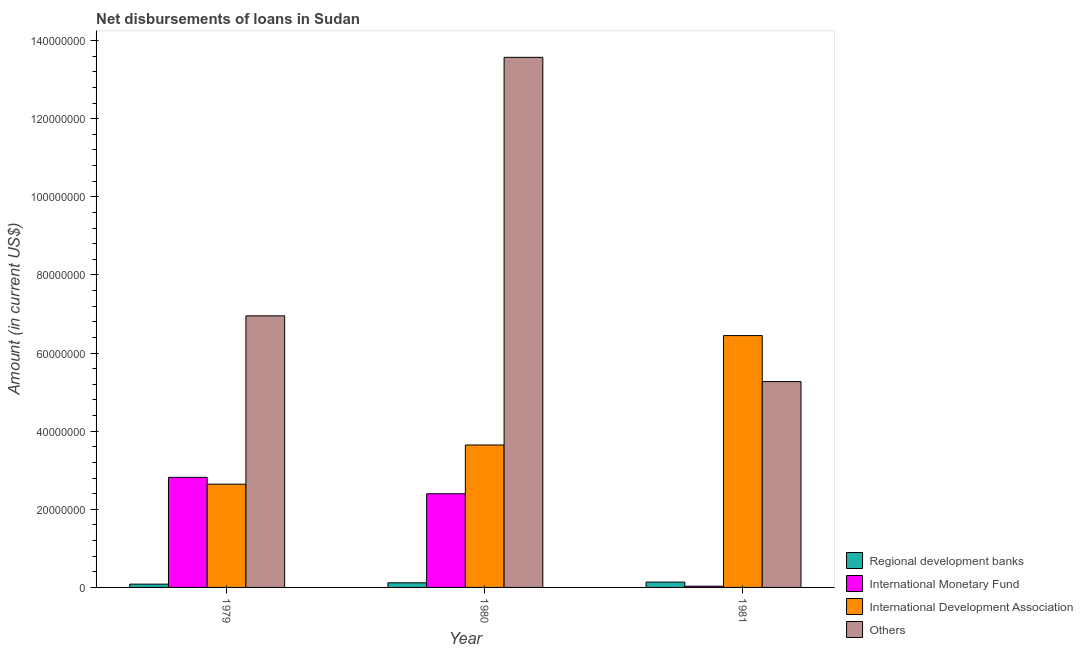Are the number of bars on each tick of the X-axis equal?
Ensure brevity in your answer.  Yes. What is the label of the 1st group of bars from the left?
Provide a succinct answer. 1979. What is the amount of loan disimbursed by international monetary fund in 1979?
Your answer should be very brief. 2.82e+07. Across all years, what is the maximum amount of loan disimbursed by other organisations?
Your answer should be compact. 1.36e+08. Across all years, what is the minimum amount of loan disimbursed by international monetary fund?
Your answer should be compact. 3.20e+05. In which year was the amount of loan disimbursed by international monetary fund maximum?
Your answer should be very brief. 1979. What is the total amount of loan disimbursed by international monetary fund in the graph?
Offer a terse response. 5.25e+07. What is the difference between the amount of loan disimbursed by international development association in 1980 and that in 1981?
Provide a short and direct response. -2.80e+07. What is the difference between the amount of loan disimbursed by other organisations in 1981 and the amount of loan disimbursed by international development association in 1980?
Offer a very short reply. -8.30e+07. What is the average amount of loan disimbursed by international monetary fund per year?
Offer a very short reply. 1.75e+07. In the year 1981, what is the difference between the amount of loan disimbursed by regional development banks and amount of loan disimbursed by international monetary fund?
Your answer should be very brief. 0. What is the ratio of the amount of loan disimbursed by international development association in 1979 to that in 1981?
Offer a terse response. 0.41. Is the amount of loan disimbursed by international development association in 1979 less than that in 1981?
Provide a short and direct response. Yes. Is the difference between the amount of loan disimbursed by international development association in 1979 and 1980 greater than the difference between the amount of loan disimbursed by international monetary fund in 1979 and 1980?
Provide a short and direct response. No. What is the difference between the highest and the second highest amount of loan disimbursed by other organisations?
Offer a very short reply. 6.62e+07. What is the difference between the highest and the lowest amount of loan disimbursed by international development association?
Your answer should be very brief. 3.80e+07. Is the sum of the amount of loan disimbursed by international development association in 1979 and 1981 greater than the maximum amount of loan disimbursed by international monetary fund across all years?
Your response must be concise. Yes. Is it the case that in every year, the sum of the amount of loan disimbursed by international monetary fund and amount of loan disimbursed by international development association is greater than the sum of amount of loan disimbursed by regional development banks and amount of loan disimbursed by other organisations?
Give a very brief answer. No. What does the 2nd bar from the left in 1980 represents?
Offer a very short reply. International Monetary Fund. What does the 2nd bar from the right in 1979 represents?
Make the answer very short. International Development Association. Is it the case that in every year, the sum of the amount of loan disimbursed by regional development banks and amount of loan disimbursed by international monetary fund is greater than the amount of loan disimbursed by international development association?
Your answer should be very brief. No. How many bars are there?
Offer a very short reply. 12. Are all the bars in the graph horizontal?
Your response must be concise. No. How many years are there in the graph?
Your answer should be very brief. 3. Does the graph contain grids?
Your answer should be compact. No. Where does the legend appear in the graph?
Your answer should be compact. Bottom right. How are the legend labels stacked?
Offer a terse response. Vertical. What is the title of the graph?
Your answer should be very brief. Net disbursements of loans in Sudan. What is the label or title of the Y-axis?
Give a very brief answer. Amount (in current US$). What is the Amount (in current US$) of Regional development banks in 1979?
Offer a very short reply. 8.43e+05. What is the Amount (in current US$) in International Monetary Fund in 1979?
Provide a succinct answer. 2.82e+07. What is the Amount (in current US$) of International Development Association in 1979?
Provide a short and direct response. 2.64e+07. What is the Amount (in current US$) of Others in 1979?
Your answer should be compact. 6.95e+07. What is the Amount (in current US$) in Regional development banks in 1980?
Provide a short and direct response. 1.19e+06. What is the Amount (in current US$) of International Monetary Fund in 1980?
Your answer should be very brief. 2.40e+07. What is the Amount (in current US$) of International Development Association in 1980?
Your answer should be very brief. 3.65e+07. What is the Amount (in current US$) in Others in 1980?
Your answer should be very brief. 1.36e+08. What is the Amount (in current US$) of Regional development banks in 1981?
Your answer should be very brief. 1.37e+06. What is the Amount (in current US$) of International Development Association in 1981?
Make the answer very short. 6.45e+07. What is the Amount (in current US$) of Others in 1981?
Your answer should be compact. 5.27e+07. Across all years, what is the maximum Amount (in current US$) in Regional development banks?
Offer a very short reply. 1.37e+06. Across all years, what is the maximum Amount (in current US$) in International Monetary Fund?
Your answer should be very brief. 2.82e+07. Across all years, what is the maximum Amount (in current US$) in International Development Association?
Offer a very short reply. 6.45e+07. Across all years, what is the maximum Amount (in current US$) of Others?
Ensure brevity in your answer.  1.36e+08. Across all years, what is the minimum Amount (in current US$) in Regional development banks?
Make the answer very short. 8.43e+05. Across all years, what is the minimum Amount (in current US$) of International Monetary Fund?
Offer a terse response. 3.20e+05. Across all years, what is the minimum Amount (in current US$) of International Development Association?
Make the answer very short. 2.64e+07. Across all years, what is the minimum Amount (in current US$) of Others?
Give a very brief answer. 5.27e+07. What is the total Amount (in current US$) in Regional development banks in the graph?
Provide a short and direct response. 3.40e+06. What is the total Amount (in current US$) of International Monetary Fund in the graph?
Make the answer very short. 5.25e+07. What is the total Amount (in current US$) of International Development Association in the graph?
Make the answer very short. 1.27e+08. What is the total Amount (in current US$) in Others in the graph?
Your answer should be very brief. 2.58e+08. What is the difference between the Amount (in current US$) of Regional development banks in 1979 and that in 1980?
Provide a short and direct response. -3.46e+05. What is the difference between the Amount (in current US$) in International Monetary Fund in 1979 and that in 1980?
Your answer should be compact. 4.20e+06. What is the difference between the Amount (in current US$) in International Development Association in 1979 and that in 1980?
Give a very brief answer. -1.00e+07. What is the difference between the Amount (in current US$) of Others in 1979 and that in 1980?
Your answer should be compact. -6.62e+07. What is the difference between the Amount (in current US$) in Regional development banks in 1979 and that in 1981?
Offer a very short reply. -5.29e+05. What is the difference between the Amount (in current US$) in International Monetary Fund in 1979 and that in 1981?
Offer a terse response. 2.79e+07. What is the difference between the Amount (in current US$) of International Development Association in 1979 and that in 1981?
Give a very brief answer. -3.80e+07. What is the difference between the Amount (in current US$) of Others in 1979 and that in 1981?
Ensure brevity in your answer.  1.68e+07. What is the difference between the Amount (in current US$) in Regional development banks in 1980 and that in 1981?
Ensure brevity in your answer.  -1.83e+05. What is the difference between the Amount (in current US$) in International Monetary Fund in 1980 and that in 1981?
Offer a very short reply. 2.37e+07. What is the difference between the Amount (in current US$) of International Development Association in 1980 and that in 1981?
Your response must be concise. -2.80e+07. What is the difference between the Amount (in current US$) in Others in 1980 and that in 1981?
Give a very brief answer. 8.30e+07. What is the difference between the Amount (in current US$) of Regional development banks in 1979 and the Amount (in current US$) of International Monetary Fund in 1980?
Keep it short and to the point. -2.31e+07. What is the difference between the Amount (in current US$) in Regional development banks in 1979 and the Amount (in current US$) in International Development Association in 1980?
Offer a terse response. -3.56e+07. What is the difference between the Amount (in current US$) in Regional development banks in 1979 and the Amount (in current US$) in Others in 1980?
Your answer should be compact. -1.35e+08. What is the difference between the Amount (in current US$) in International Monetary Fund in 1979 and the Amount (in current US$) in International Development Association in 1980?
Provide a succinct answer. -8.28e+06. What is the difference between the Amount (in current US$) of International Monetary Fund in 1979 and the Amount (in current US$) of Others in 1980?
Give a very brief answer. -1.08e+08. What is the difference between the Amount (in current US$) of International Development Association in 1979 and the Amount (in current US$) of Others in 1980?
Keep it short and to the point. -1.09e+08. What is the difference between the Amount (in current US$) in Regional development banks in 1979 and the Amount (in current US$) in International Monetary Fund in 1981?
Your response must be concise. 5.23e+05. What is the difference between the Amount (in current US$) in Regional development banks in 1979 and the Amount (in current US$) in International Development Association in 1981?
Ensure brevity in your answer.  -6.36e+07. What is the difference between the Amount (in current US$) of Regional development banks in 1979 and the Amount (in current US$) of Others in 1981?
Keep it short and to the point. -5.19e+07. What is the difference between the Amount (in current US$) of International Monetary Fund in 1979 and the Amount (in current US$) of International Development Association in 1981?
Your answer should be compact. -3.63e+07. What is the difference between the Amount (in current US$) in International Monetary Fund in 1979 and the Amount (in current US$) in Others in 1981?
Your response must be concise. -2.45e+07. What is the difference between the Amount (in current US$) in International Development Association in 1979 and the Amount (in current US$) in Others in 1981?
Give a very brief answer. -2.63e+07. What is the difference between the Amount (in current US$) of Regional development banks in 1980 and the Amount (in current US$) of International Monetary Fund in 1981?
Keep it short and to the point. 8.69e+05. What is the difference between the Amount (in current US$) of Regional development banks in 1980 and the Amount (in current US$) of International Development Association in 1981?
Provide a short and direct response. -6.33e+07. What is the difference between the Amount (in current US$) of Regional development banks in 1980 and the Amount (in current US$) of Others in 1981?
Offer a very short reply. -5.15e+07. What is the difference between the Amount (in current US$) of International Monetary Fund in 1980 and the Amount (in current US$) of International Development Association in 1981?
Give a very brief answer. -4.05e+07. What is the difference between the Amount (in current US$) of International Monetary Fund in 1980 and the Amount (in current US$) of Others in 1981?
Your answer should be very brief. -2.87e+07. What is the difference between the Amount (in current US$) in International Development Association in 1980 and the Amount (in current US$) in Others in 1981?
Offer a very short reply. -1.62e+07. What is the average Amount (in current US$) in Regional development banks per year?
Your response must be concise. 1.13e+06. What is the average Amount (in current US$) of International Monetary Fund per year?
Provide a succinct answer. 1.75e+07. What is the average Amount (in current US$) in International Development Association per year?
Your answer should be compact. 4.25e+07. What is the average Amount (in current US$) of Others per year?
Offer a very short reply. 8.60e+07. In the year 1979, what is the difference between the Amount (in current US$) in Regional development banks and Amount (in current US$) in International Monetary Fund?
Keep it short and to the point. -2.73e+07. In the year 1979, what is the difference between the Amount (in current US$) of Regional development banks and Amount (in current US$) of International Development Association?
Ensure brevity in your answer.  -2.56e+07. In the year 1979, what is the difference between the Amount (in current US$) in Regional development banks and Amount (in current US$) in Others?
Provide a succinct answer. -6.87e+07. In the year 1979, what is the difference between the Amount (in current US$) of International Monetary Fund and Amount (in current US$) of International Development Association?
Your answer should be compact. 1.76e+06. In the year 1979, what is the difference between the Amount (in current US$) in International Monetary Fund and Amount (in current US$) in Others?
Your answer should be compact. -4.13e+07. In the year 1979, what is the difference between the Amount (in current US$) of International Development Association and Amount (in current US$) of Others?
Offer a very short reply. -4.31e+07. In the year 1980, what is the difference between the Amount (in current US$) of Regional development banks and Amount (in current US$) of International Monetary Fund?
Your response must be concise. -2.28e+07. In the year 1980, what is the difference between the Amount (in current US$) in Regional development banks and Amount (in current US$) in International Development Association?
Ensure brevity in your answer.  -3.53e+07. In the year 1980, what is the difference between the Amount (in current US$) in Regional development banks and Amount (in current US$) in Others?
Give a very brief answer. -1.35e+08. In the year 1980, what is the difference between the Amount (in current US$) of International Monetary Fund and Amount (in current US$) of International Development Association?
Your answer should be compact. -1.25e+07. In the year 1980, what is the difference between the Amount (in current US$) of International Monetary Fund and Amount (in current US$) of Others?
Keep it short and to the point. -1.12e+08. In the year 1980, what is the difference between the Amount (in current US$) of International Development Association and Amount (in current US$) of Others?
Make the answer very short. -9.93e+07. In the year 1981, what is the difference between the Amount (in current US$) of Regional development banks and Amount (in current US$) of International Monetary Fund?
Your answer should be very brief. 1.05e+06. In the year 1981, what is the difference between the Amount (in current US$) of Regional development banks and Amount (in current US$) of International Development Association?
Ensure brevity in your answer.  -6.31e+07. In the year 1981, what is the difference between the Amount (in current US$) of Regional development banks and Amount (in current US$) of Others?
Offer a terse response. -5.13e+07. In the year 1981, what is the difference between the Amount (in current US$) of International Monetary Fund and Amount (in current US$) of International Development Association?
Offer a terse response. -6.42e+07. In the year 1981, what is the difference between the Amount (in current US$) in International Monetary Fund and Amount (in current US$) in Others?
Provide a short and direct response. -5.24e+07. In the year 1981, what is the difference between the Amount (in current US$) in International Development Association and Amount (in current US$) in Others?
Offer a very short reply. 1.18e+07. What is the ratio of the Amount (in current US$) of Regional development banks in 1979 to that in 1980?
Offer a very short reply. 0.71. What is the ratio of the Amount (in current US$) of International Monetary Fund in 1979 to that in 1980?
Keep it short and to the point. 1.17. What is the ratio of the Amount (in current US$) of International Development Association in 1979 to that in 1980?
Give a very brief answer. 0.72. What is the ratio of the Amount (in current US$) in Others in 1979 to that in 1980?
Your response must be concise. 0.51. What is the ratio of the Amount (in current US$) in Regional development banks in 1979 to that in 1981?
Your answer should be very brief. 0.61. What is the ratio of the Amount (in current US$) of International Monetary Fund in 1979 to that in 1981?
Give a very brief answer. 88.08. What is the ratio of the Amount (in current US$) in International Development Association in 1979 to that in 1981?
Ensure brevity in your answer.  0.41. What is the ratio of the Amount (in current US$) in Others in 1979 to that in 1981?
Ensure brevity in your answer.  1.32. What is the ratio of the Amount (in current US$) in Regional development banks in 1980 to that in 1981?
Offer a terse response. 0.87. What is the ratio of the Amount (in current US$) of International Monetary Fund in 1980 to that in 1981?
Offer a terse response. 74.97. What is the ratio of the Amount (in current US$) in International Development Association in 1980 to that in 1981?
Provide a succinct answer. 0.57. What is the ratio of the Amount (in current US$) of Others in 1980 to that in 1981?
Your response must be concise. 2.58. What is the difference between the highest and the second highest Amount (in current US$) in Regional development banks?
Your answer should be very brief. 1.83e+05. What is the difference between the highest and the second highest Amount (in current US$) in International Monetary Fund?
Your answer should be compact. 4.20e+06. What is the difference between the highest and the second highest Amount (in current US$) of International Development Association?
Give a very brief answer. 2.80e+07. What is the difference between the highest and the second highest Amount (in current US$) in Others?
Your answer should be compact. 6.62e+07. What is the difference between the highest and the lowest Amount (in current US$) in Regional development banks?
Your response must be concise. 5.29e+05. What is the difference between the highest and the lowest Amount (in current US$) in International Monetary Fund?
Provide a short and direct response. 2.79e+07. What is the difference between the highest and the lowest Amount (in current US$) in International Development Association?
Offer a terse response. 3.80e+07. What is the difference between the highest and the lowest Amount (in current US$) of Others?
Provide a short and direct response. 8.30e+07. 